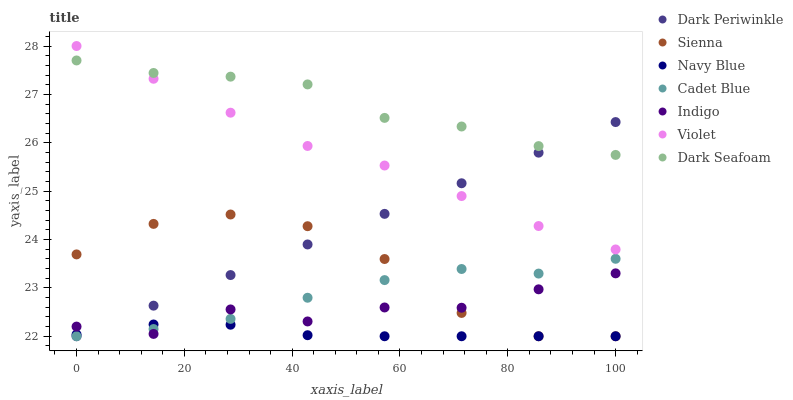Does Navy Blue have the minimum area under the curve?
Answer yes or no. Yes. Does Dark Seafoam have the maximum area under the curve?
Answer yes or no. Yes. Does Indigo have the minimum area under the curve?
Answer yes or no. No. Does Indigo have the maximum area under the curve?
Answer yes or no. No. Is Dark Periwinkle the smoothest?
Answer yes or no. Yes. Is Sienna the roughest?
Answer yes or no. Yes. Is Indigo the smoothest?
Answer yes or no. No. Is Indigo the roughest?
Answer yes or no. No. Does Cadet Blue have the lowest value?
Answer yes or no. Yes. Does Indigo have the lowest value?
Answer yes or no. No. Does Violet have the highest value?
Answer yes or no. Yes. Does Indigo have the highest value?
Answer yes or no. No. Is Indigo less than Dark Seafoam?
Answer yes or no. Yes. Is Violet greater than Indigo?
Answer yes or no. Yes. Does Dark Periwinkle intersect Indigo?
Answer yes or no. Yes. Is Dark Periwinkle less than Indigo?
Answer yes or no. No. Is Dark Periwinkle greater than Indigo?
Answer yes or no. No. Does Indigo intersect Dark Seafoam?
Answer yes or no. No. 